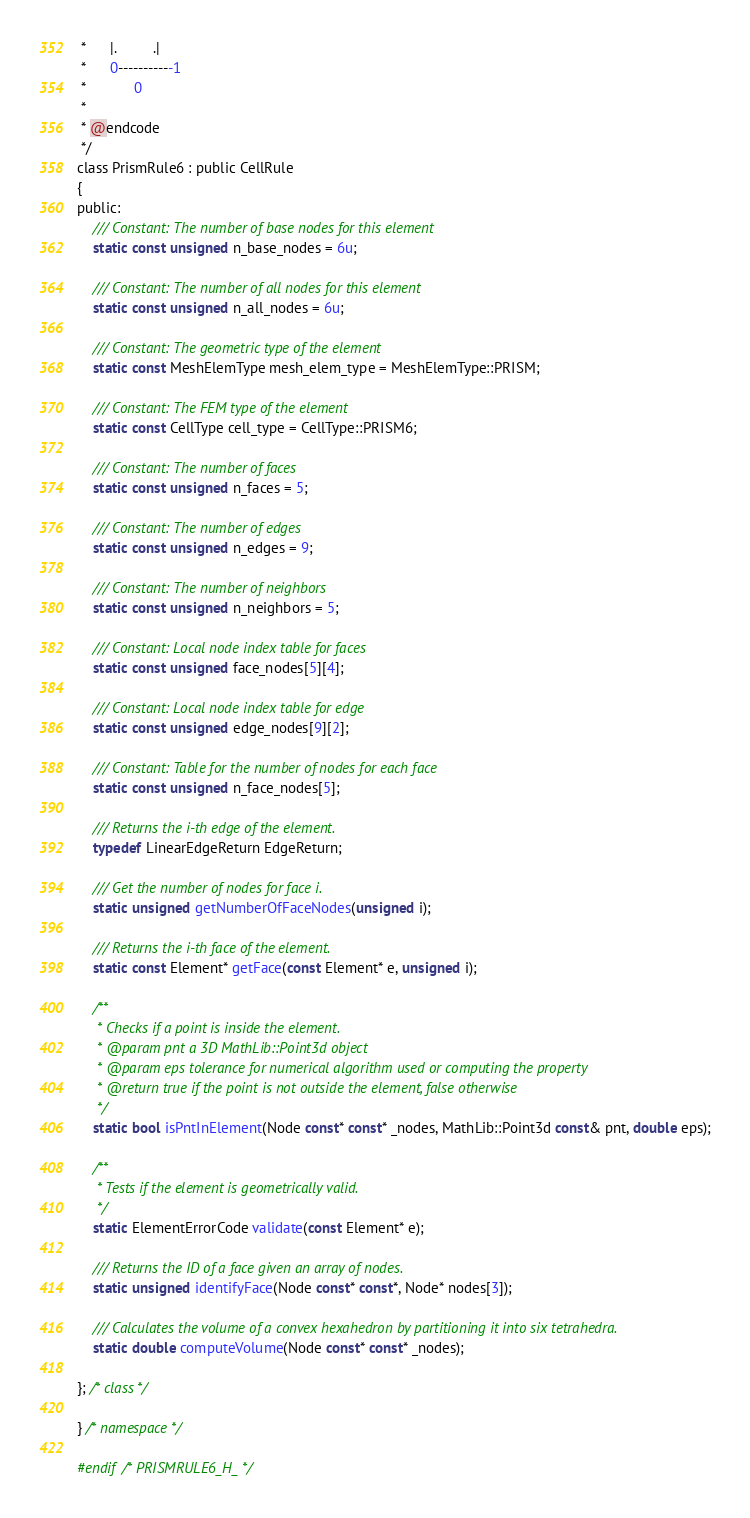<code> <loc_0><loc_0><loc_500><loc_500><_C_> *      |.         .|
 *      0-----------1
 *            0
 *
 * @endcode
 */
class PrismRule6 : public CellRule
{
public:
    /// Constant: The number of base nodes for this element
    static const unsigned n_base_nodes = 6u;

    /// Constant: The number of all nodes for this element
    static const unsigned n_all_nodes = 6u;

    /// Constant: The geometric type of the element
    static const MeshElemType mesh_elem_type = MeshElemType::PRISM;

    /// Constant: The FEM type of the element
    static const CellType cell_type = CellType::PRISM6;

    /// Constant: The number of faces
    static const unsigned n_faces = 5;

    /// Constant: The number of edges
    static const unsigned n_edges = 9;

    /// Constant: The number of neighbors
    static const unsigned n_neighbors = 5;

    /// Constant: Local node index table for faces
    static const unsigned face_nodes[5][4];

    /// Constant: Local node index table for edge
    static const unsigned edge_nodes[9][2];

    /// Constant: Table for the number of nodes for each face
    static const unsigned n_face_nodes[5];

    /// Returns the i-th edge of the element.
    typedef LinearEdgeReturn EdgeReturn;

    /// Get the number of nodes for face i.
    static unsigned getNumberOfFaceNodes(unsigned i);

    /// Returns the i-th face of the element.
    static const Element* getFace(const Element* e, unsigned i);

    /**
     * Checks if a point is inside the element.
     * @param pnt a 3D MathLib::Point3d object
     * @param eps tolerance for numerical algorithm used or computing the property
     * @return true if the point is not outside the element, false otherwise
     */
    static bool isPntInElement(Node const* const* _nodes, MathLib::Point3d const& pnt, double eps);

    /**
     * Tests if the element is geometrically valid.
     */
    static ElementErrorCode validate(const Element* e);

    /// Returns the ID of a face given an array of nodes.
    static unsigned identifyFace(Node const* const*, Node* nodes[3]);

    /// Calculates the volume of a convex hexahedron by partitioning it into six tetrahedra.
    static double computeVolume(Node const* const* _nodes);

}; /* class */

} /* namespace */

#endif /* PRISMRULE6_H_ */

</code> 